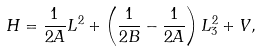Convert formula to latex. <formula><loc_0><loc_0><loc_500><loc_500>H = \frac { 1 } { 2 A } { L } ^ { 2 } + \left ( \frac { 1 } { 2 B } - \frac { 1 } { 2 A } \right ) L _ { 3 } ^ { 2 } + V ,</formula> 